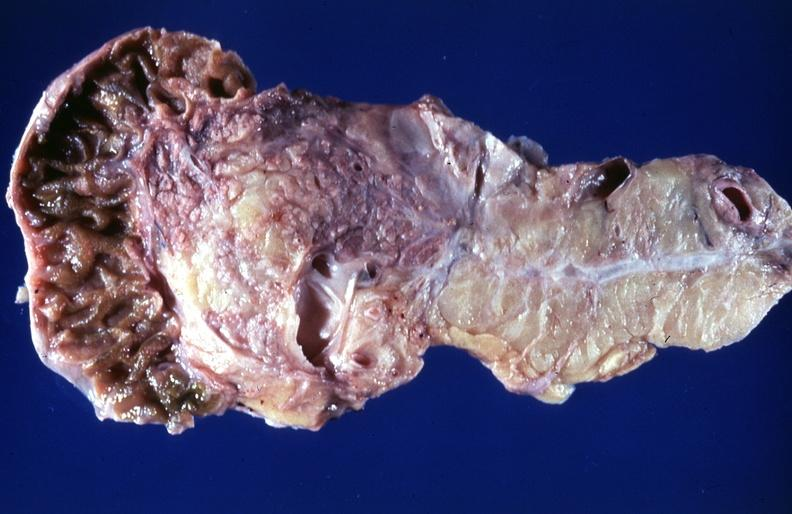s pancreas present?
Answer the question using a single word or phrase. Yes 